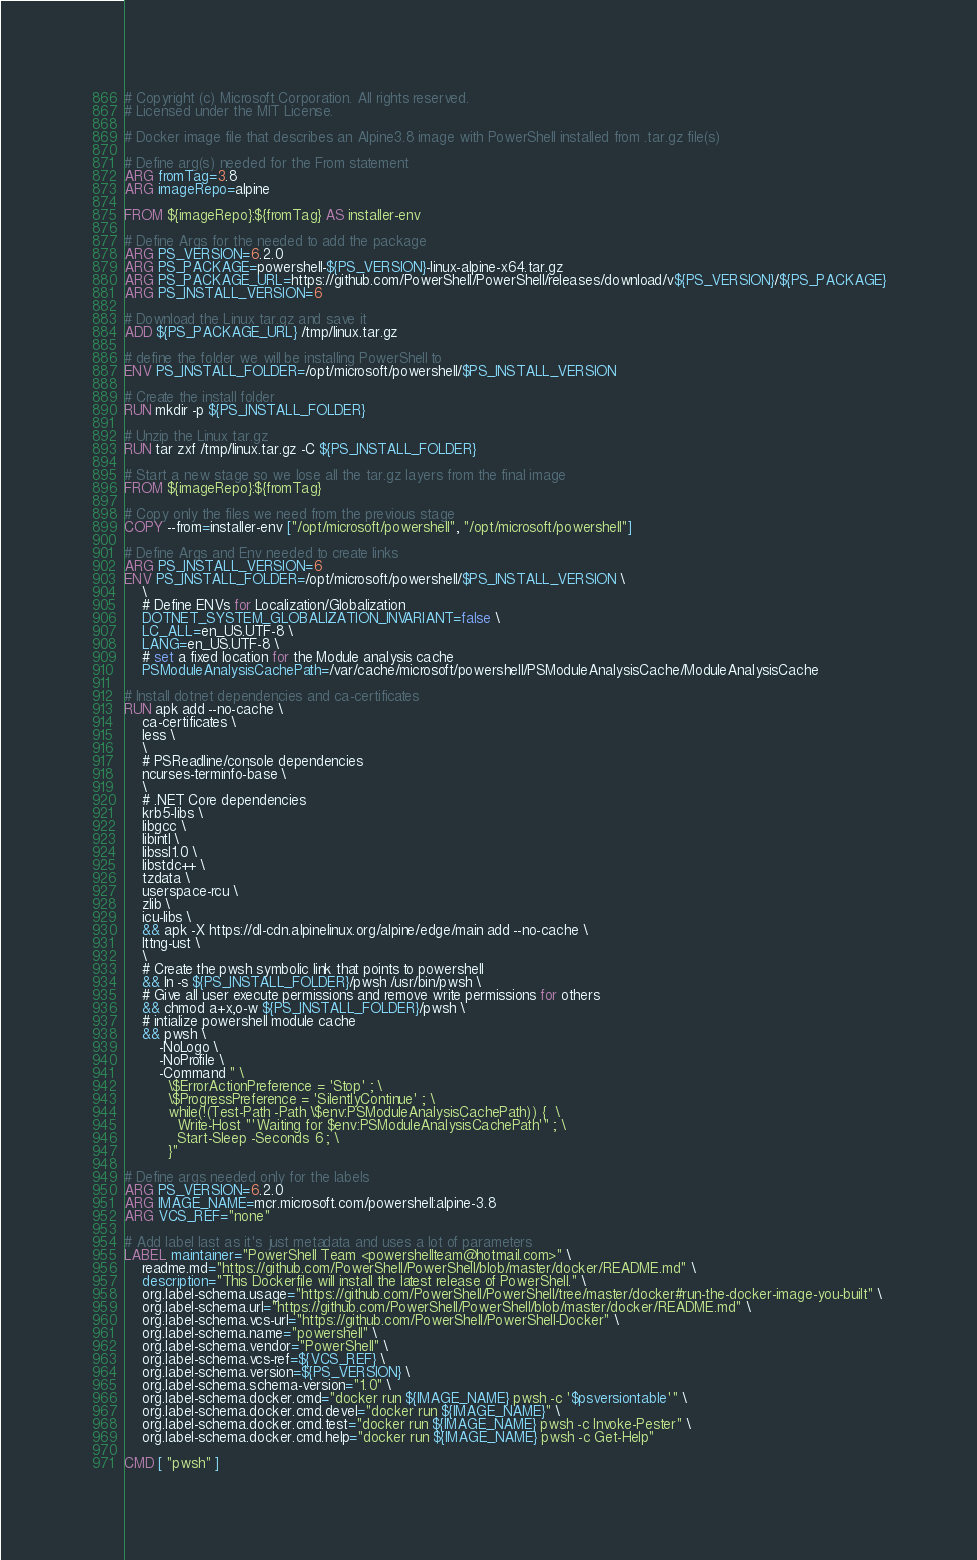Convert code to text. <code><loc_0><loc_0><loc_500><loc_500><_Dockerfile_># Copyright (c) Microsoft Corporation. All rights reserved.
# Licensed under the MIT License.

# Docker image file that describes an Alpine3.8 image with PowerShell installed from .tar.gz file(s)

# Define arg(s) needed for the From statement
ARG fromTag=3.8
ARG imageRepo=alpine

FROM ${imageRepo}:${fromTag} AS installer-env

# Define Args for the needed to add the package
ARG PS_VERSION=6.2.0
ARG PS_PACKAGE=powershell-${PS_VERSION}-linux-alpine-x64.tar.gz
ARG PS_PACKAGE_URL=https://github.com/PowerShell/PowerShell/releases/download/v${PS_VERSION}/${PS_PACKAGE}
ARG PS_INSTALL_VERSION=6

# Download the Linux tar.gz and save it
ADD ${PS_PACKAGE_URL} /tmp/linux.tar.gz

# define the folder we will be installing PowerShell to
ENV PS_INSTALL_FOLDER=/opt/microsoft/powershell/$PS_INSTALL_VERSION

# Create the install folder
RUN mkdir -p ${PS_INSTALL_FOLDER}

# Unzip the Linux tar.gz
RUN tar zxf /tmp/linux.tar.gz -C ${PS_INSTALL_FOLDER}

# Start a new stage so we lose all the tar.gz layers from the final image
FROM ${imageRepo}:${fromTag}

# Copy only the files we need from the previous stage
COPY --from=installer-env ["/opt/microsoft/powershell", "/opt/microsoft/powershell"]

# Define Args and Env needed to create links
ARG PS_INSTALL_VERSION=6
ENV PS_INSTALL_FOLDER=/opt/microsoft/powershell/$PS_INSTALL_VERSION \
    \
    # Define ENVs for Localization/Globalization
    DOTNET_SYSTEM_GLOBALIZATION_INVARIANT=false \
    LC_ALL=en_US.UTF-8 \
    LANG=en_US.UTF-8 \
    # set a fixed location for the Module analysis cache
    PSModuleAnalysisCachePath=/var/cache/microsoft/powershell/PSModuleAnalysisCache/ModuleAnalysisCache

# Install dotnet dependencies and ca-certificates
RUN apk add --no-cache \
    ca-certificates \
    less \
    \
    # PSReadline/console dependencies
    ncurses-terminfo-base \
    \
    # .NET Core dependencies
    krb5-libs \
    libgcc \
    libintl \
    libssl1.0 \
    libstdc++ \
    tzdata \
    userspace-rcu \
    zlib \
    icu-libs \
    && apk -X https://dl-cdn.alpinelinux.org/alpine/edge/main add --no-cache \
    lttng-ust \
    \
    # Create the pwsh symbolic link that points to powershell
    && ln -s ${PS_INSTALL_FOLDER}/pwsh /usr/bin/pwsh \
    # Give all user execute permissions and remove write permissions for others
    && chmod a+x,o-w ${PS_INSTALL_FOLDER}/pwsh \
    # intialize powershell module cache
    && pwsh \
        -NoLogo \
        -NoProfile \
        -Command " \
          \$ErrorActionPreference = 'Stop' ; \
          \$ProgressPreference = 'SilentlyContinue' ; \
          while(!(Test-Path -Path \$env:PSModuleAnalysisCachePath)) {  \
            Write-Host "'Waiting for $env:PSModuleAnalysisCachePath'" ; \
            Start-Sleep -Seconds 6 ; \
          }"

# Define args needed only for the labels
ARG PS_VERSION=6.2.0
ARG IMAGE_NAME=mcr.microsoft.com/powershell:alpine-3.8
ARG VCS_REF="none"

# Add label last as it's just metadata and uses a lot of parameters
LABEL maintainer="PowerShell Team <powershellteam@hotmail.com>" \
    readme.md="https://github.com/PowerShell/PowerShell/blob/master/docker/README.md" \
    description="This Dockerfile will install the latest release of PowerShell." \
    org.label-schema.usage="https://github.com/PowerShell/PowerShell/tree/master/docker#run-the-docker-image-you-built" \
    org.label-schema.url="https://github.com/PowerShell/PowerShell/blob/master/docker/README.md" \
    org.label-schema.vcs-url="https://github.com/PowerShell/PowerShell-Docker" \
    org.label-schema.name="powershell" \
    org.label-schema.vendor="PowerShell" \
    org.label-schema.vcs-ref=${VCS_REF} \
    org.label-schema.version=${PS_VERSION} \
    org.label-schema.schema-version="1.0" \
    org.label-schema.docker.cmd="docker run ${IMAGE_NAME} pwsh -c '$psversiontable'" \
    org.label-schema.docker.cmd.devel="docker run ${IMAGE_NAME}" \
    org.label-schema.docker.cmd.test="docker run ${IMAGE_NAME} pwsh -c Invoke-Pester" \
    org.label-schema.docker.cmd.help="docker run ${IMAGE_NAME} pwsh -c Get-Help"

CMD [ "pwsh" ]
</code> 